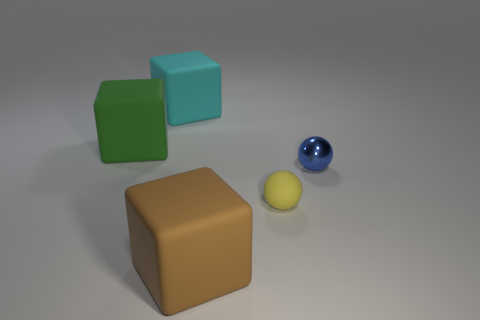There is a rubber object that is on the right side of the cube that is in front of the tiny shiny thing; what number of spheres are to the right of it?
Make the answer very short. 1. Do the rubber ball and the tiny shiny thing have the same color?
Make the answer very short. No. What number of things are both behind the tiny yellow sphere and to the left of the small metallic sphere?
Provide a short and direct response. 2. The tiny thing on the right side of the small rubber object has what shape?
Make the answer very short. Sphere. Are there fewer small yellow matte objects left of the cyan rubber thing than green objects that are in front of the big green block?
Make the answer very short. No. Are the sphere behind the tiny rubber ball and the cube that is behind the large green rubber thing made of the same material?
Give a very brief answer. No. There is a large cyan thing; what shape is it?
Your response must be concise. Cube. Are there more brown objects that are to the left of the big brown cube than tiny objects that are behind the cyan matte thing?
Make the answer very short. No. Is the shape of the big matte thing that is left of the large cyan cube the same as the big rubber thing that is in front of the blue shiny thing?
Ensure brevity in your answer.  Yes. How many other objects are there of the same size as the green thing?
Give a very brief answer. 2. 